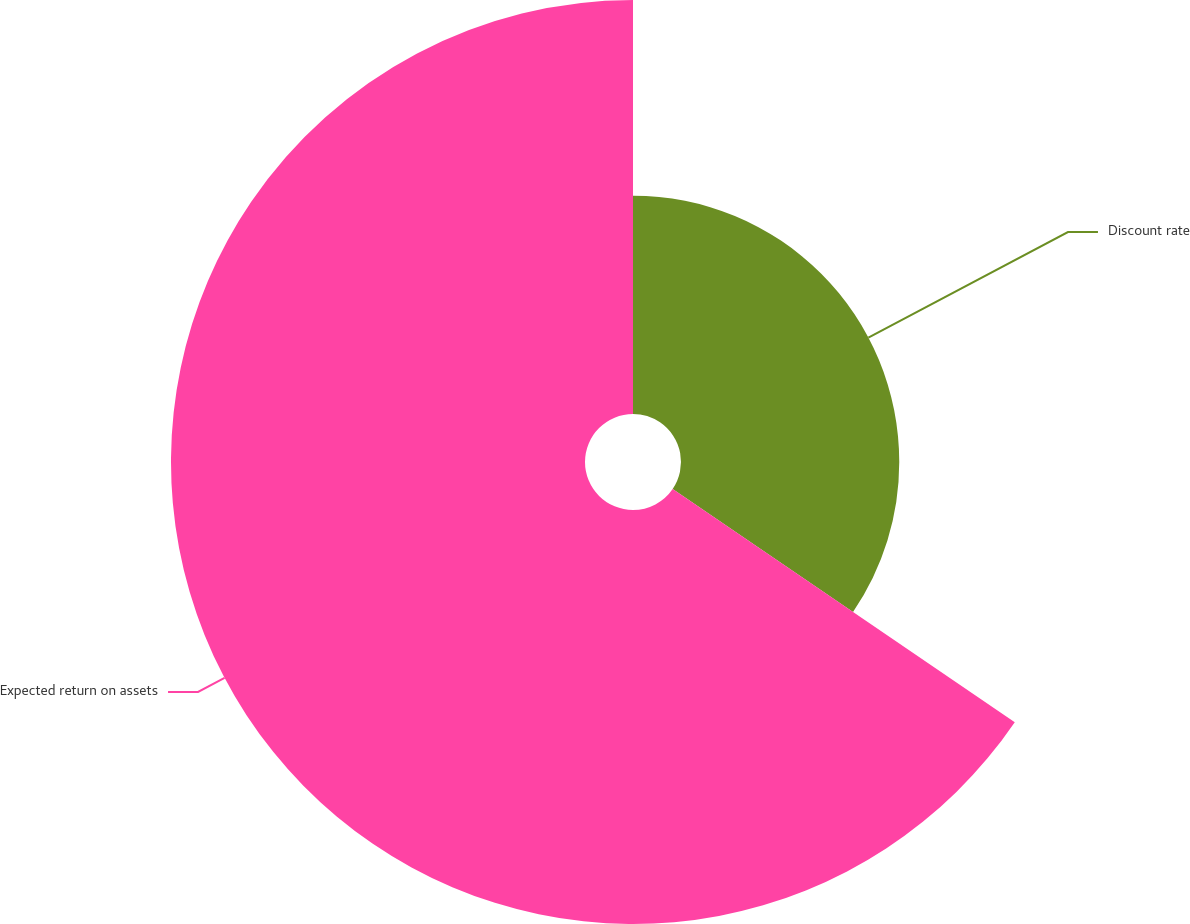Convert chart. <chart><loc_0><loc_0><loc_500><loc_500><pie_chart><fcel>Discount rate<fcel>Expected return on assets<nl><fcel>34.52%<fcel>65.48%<nl></chart> 